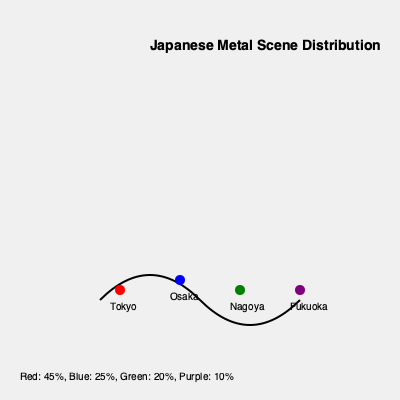Based on the map of Japan showing the distribution of metal record labels and bands, which city appears to be the epicenter of the Japanese metal scene, and approximately what percentage of the scene does it represent? To answer this question, we need to analyze the information provided in the map:

1. The map shows four major cities in Japan: Tokyo, Osaka, Nagoya, and Fukuoka.
2. Each city is represented by a colored circle: Tokyo (red), Osaka (blue), Nagoya (green), and Fukuoka (purple).
3. The legend at the bottom of the map provides percentage distributions:
   - Red (Tokyo): 45%
   - Blue (Osaka): 25%
   - Green (Nagoya): 20%
   - Purple (Fukuoka): 10%

4. We can see that Tokyo (red) has the highest percentage at 45%.
5. This indicates that Tokyo has the largest concentration of metal record labels and bands among the cities shown.
6. The 45% figure suggests that nearly half of the Japanese metal scene is centered in Tokyo.

Therefore, based on this data, Tokyo appears to be the epicenter of the Japanese metal scene, representing approximately 45% of the total distribution.
Answer: Tokyo, 45% 